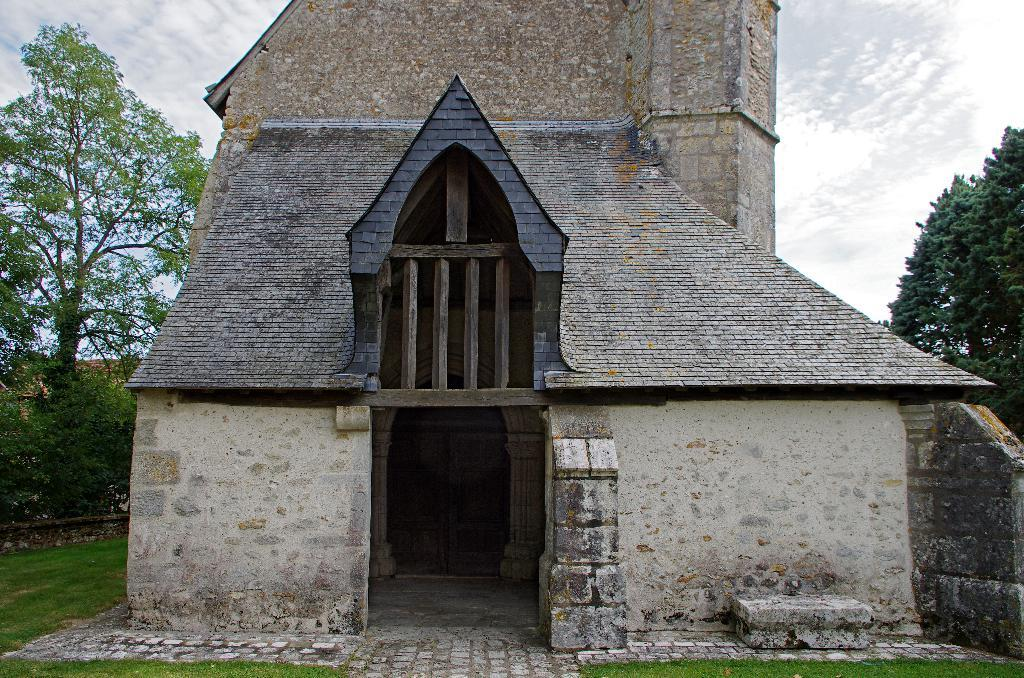What type of structure is present in the image? There is a building in the image. What type of vegetation can be seen in the image? There is grass, plants, and trees in the image. What is visible at the top of the image? The sky is visible at the top of the image. What type of comb is being used in the discussion in the image? There is no comb or discussion present in the image. What type of sheet is covering the trees in the image? There is no sheet covering the trees in the image; the trees are visible without any covering. 